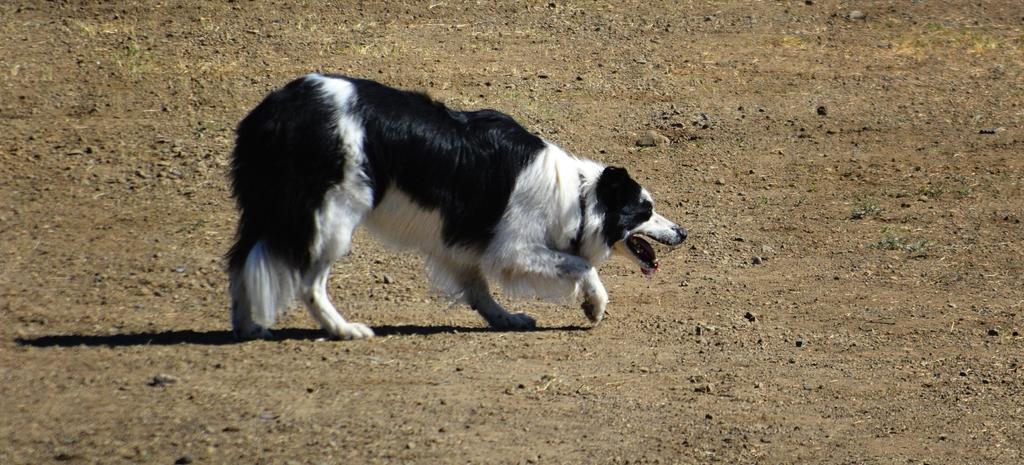In one or two sentences, can you explain what this image depicts? In this image I can see a dog which is black and white in color on the ground which is brown in color. 